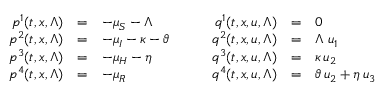Convert formula to latex. <formula><loc_0><loc_0><loc_500><loc_500>\begin{array} { r c l } { p ^ { 1 } ( t , x , \Lambda ) } & { = } & { - \mu _ { S } - \Lambda } \\ { p ^ { 2 } ( t , x , \Lambda ) } & { = } & { - \mu _ { I } - \kappa - \vartheta } \\ { p ^ { 3 } ( t , x , \Lambda ) } & { = } & { - \mu _ { H } - \eta } \\ { p ^ { 4 } ( t , x , \Lambda ) } & { = } & { - \mu _ { R } } \end{array} \quad \begin{array} { r c l } { q ^ { 1 } ( t , x , u , \Lambda ) } & { = } & { 0 } \\ { q ^ { 2 } ( t , x , u , \Lambda ) } & { = } & { \Lambda \, u _ { 1 } } \\ { q ^ { 3 } ( t , x , u , \Lambda ) } & { = } & { \kappa \, u _ { 2 } } \\ { q ^ { 4 } ( t , x , u , \Lambda ) } & { = } & { \vartheta \, u _ { 2 } + \eta \, u _ { 3 } } \end{array}</formula> 